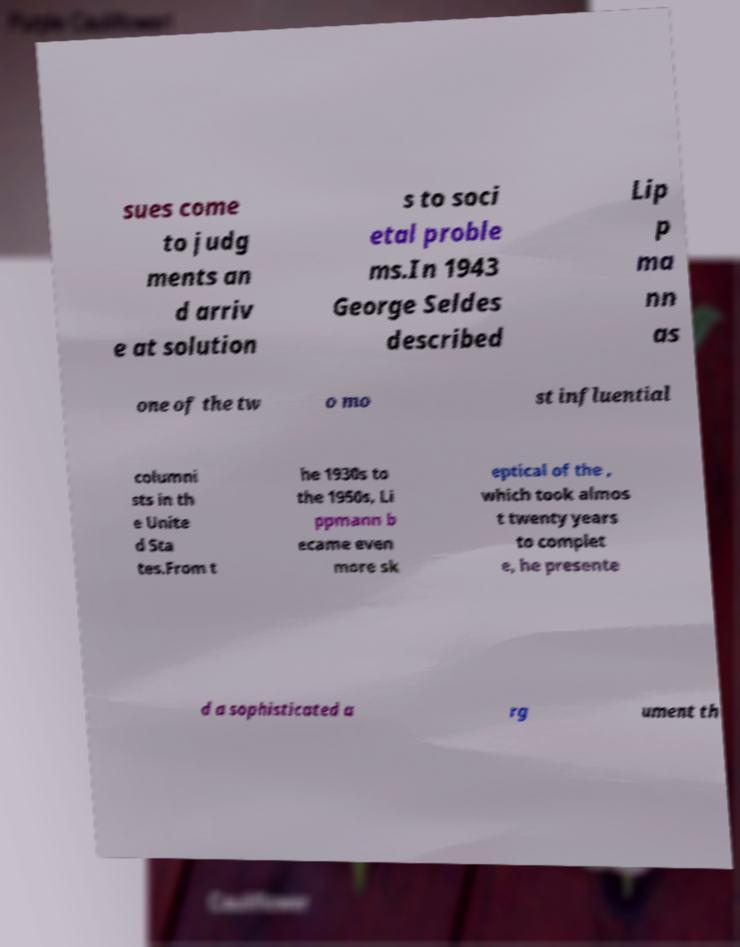I need the written content from this picture converted into text. Can you do that? sues come to judg ments an d arriv e at solution s to soci etal proble ms.In 1943 George Seldes described Lip p ma nn as one of the tw o mo st influential columni sts in th e Unite d Sta tes.From t he 1930s to the 1950s, Li ppmann b ecame even more sk eptical of the , which took almos t twenty years to complet e, he presente d a sophisticated a rg ument th 